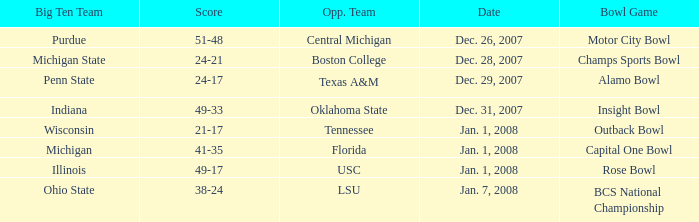What was the outcome of the bcs national championship game? 38-24. 